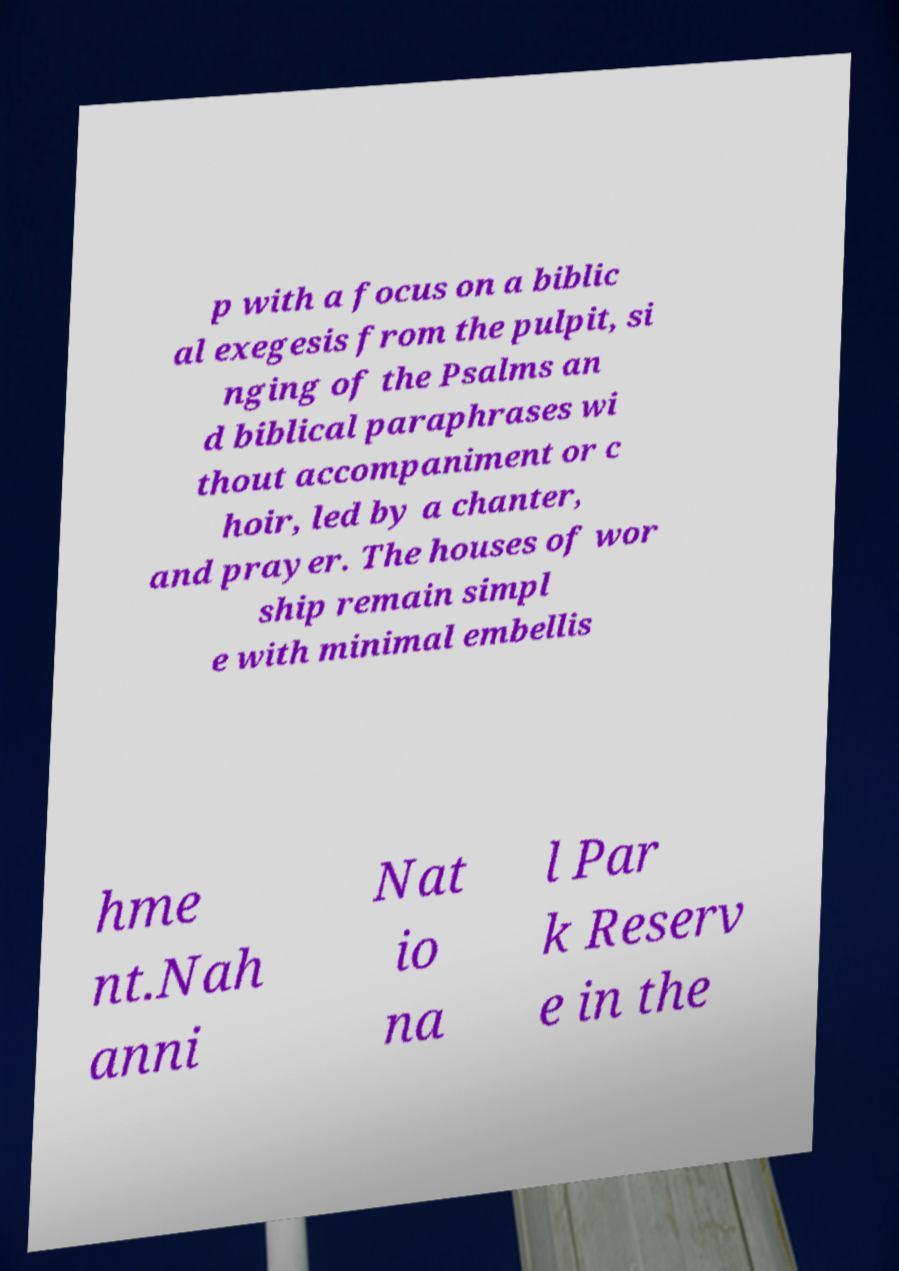Could you assist in decoding the text presented in this image and type it out clearly? p with a focus on a biblic al exegesis from the pulpit, si nging of the Psalms an d biblical paraphrases wi thout accompaniment or c hoir, led by a chanter, and prayer. The houses of wor ship remain simpl e with minimal embellis hme nt.Nah anni Nat io na l Par k Reserv e in the 